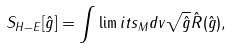Convert formula to latex. <formula><loc_0><loc_0><loc_500><loc_500>S _ { H - E } [ \hat { g } ] = \int \lim i t s _ { M } d v \sqrt { \hat { g } } \hat { R } ( \hat { g } ) ,</formula> 